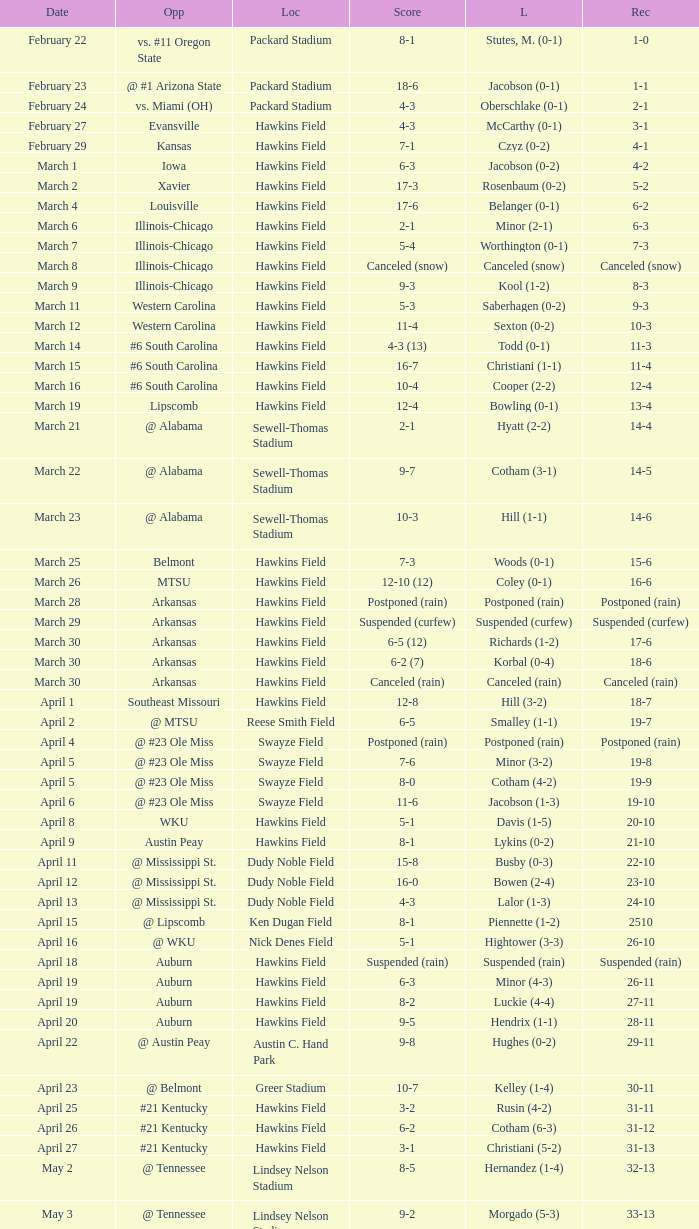What was the location of the game when the record was 12-4? Hawkins Field. Could you parse the entire table as a dict? {'header': ['Date', 'Opp', 'Loc', 'Score', 'L', 'Rec'], 'rows': [['February 22', 'vs. #11 Oregon State', 'Packard Stadium', '8-1', 'Stutes, M. (0-1)', '1-0'], ['February 23', '@ #1 Arizona State', 'Packard Stadium', '18-6', 'Jacobson (0-1)', '1-1'], ['February 24', 'vs. Miami (OH)', 'Packard Stadium', '4-3', 'Oberschlake (0-1)', '2-1'], ['February 27', 'Evansville', 'Hawkins Field', '4-3', 'McCarthy (0-1)', '3-1'], ['February 29', 'Kansas', 'Hawkins Field', '7-1', 'Czyz (0-2)', '4-1'], ['March 1', 'Iowa', 'Hawkins Field', '6-3', 'Jacobson (0-2)', '4-2'], ['March 2', 'Xavier', 'Hawkins Field', '17-3', 'Rosenbaum (0-2)', '5-2'], ['March 4', 'Louisville', 'Hawkins Field', '17-6', 'Belanger (0-1)', '6-2'], ['March 6', 'Illinois-Chicago', 'Hawkins Field', '2-1', 'Minor (2-1)', '6-3'], ['March 7', 'Illinois-Chicago', 'Hawkins Field', '5-4', 'Worthington (0-1)', '7-3'], ['March 8', 'Illinois-Chicago', 'Hawkins Field', 'Canceled (snow)', 'Canceled (snow)', 'Canceled (snow)'], ['March 9', 'Illinois-Chicago', 'Hawkins Field', '9-3', 'Kool (1-2)', '8-3'], ['March 11', 'Western Carolina', 'Hawkins Field', '5-3', 'Saberhagen (0-2)', '9-3'], ['March 12', 'Western Carolina', 'Hawkins Field', '11-4', 'Sexton (0-2)', '10-3'], ['March 14', '#6 South Carolina', 'Hawkins Field', '4-3 (13)', 'Todd (0-1)', '11-3'], ['March 15', '#6 South Carolina', 'Hawkins Field', '16-7', 'Christiani (1-1)', '11-4'], ['March 16', '#6 South Carolina', 'Hawkins Field', '10-4', 'Cooper (2-2)', '12-4'], ['March 19', 'Lipscomb', 'Hawkins Field', '12-4', 'Bowling (0-1)', '13-4'], ['March 21', '@ Alabama', 'Sewell-Thomas Stadium', '2-1', 'Hyatt (2-2)', '14-4'], ['March 22', '@ Alabama', 'Sewell-Thomas Stadium', '9-7', 'Cotham (3-1)', '14-5'], ['March 23', '@ Alabama', 'Sewell-Thomas Stadium', '10-3', 'Hill (1-1)', '14-6'], ['March 25', 'Belmont', 'Hawkins Field', '7-3', 'Woods (0-1)', '15-6'], ['March 26', 'MTSU', 'Hawkins Field', '12-10 (12)', 'Coley (0-1)', '16-6'], ['March 28', 'Arkansas', 'Hawkins Field', 'Postponed (rain)', 'Postponed (rain)', 'Postponed (rain)'], ['March 29', 'Arkansas', 'Hawkins Field', 'Suspended (curfew)', 'Suspended (curfew)', 'Suspended (curfew)'], ['March 30', 'Arkansas', 'Hawkins Field', '6-5 (12)', 'Richards (1-2)', '17-6'], ['March 30', 'Arkansas', 'Hawkins Field', '6-2 (7)', 'Korbal (0-4)', '18-6'], ['March 30', 'Arkansas', 'Hawkins Field', 'Canceled (rain)', 'Canceled (rain)', 'Canceled (rain)'], ['April 1', 'Southeast Missouri', 'Hawkins Field', '12-8', 'Hill (3-2)', '18-7'], ['April 2', '@ MTSU', 'Reese Smith Field', '6-5', 'Smalley (1-1)', '19-7'], ['April 4', '@ #23 Ole Miss', 'Swayze Field', 'Postponed (rain)', 'Postponed (rain)', 'Postponed (rain)'], ['April 5', '@ #23 Ole Miss', 'Swayze Field', '7-6', 'Minor (3-2)', '19-8'], ['April 5', '@ #23 Ole Miss', 'Swayze Field', '8-0', 'Cotham (4-2)', '19-9'], ['April 6', '@ #23 Ole Miss', 'Swayze Field', '11-6', 'Jacobson (1-3)', '19-10'], ['April 8', 'WKU', 'Hawkins Field', '5-1', 'Davis (1-5)', '20-10'], ['April 9', 'Austin Peay', 'Hawkins Field', '8-1', 'Lykins (0-2)', '21-10'], ['April 11', '@ Mississippi St.', 'Dudy Noble Field', '15-8', 'Busby (0-3)', '22-10'], ['April 12', '@ Mississippi St.', 'Dudy Noble Field', '16-0', 'Bowen (2-4)', '23-10'], ['April 13', '@ Mississippi St.', 'Dudy Noble Field', '4-3', 'Lalor (1-3)', '24-10'], ['April 15', '@ Lipscomb', 'Ken Dugan Field', '8-1', 'Piennette (1-2)', '2510'], ['April 16', '@ WKU', 'Nick Denes Field', '5-1', 'Hightower (3-3)', '26-10'], ['April 18', 'Auburn', 'Hawkins Field', 'Suspended (rain)', 'Suspended (rain)', 'Suspended (rain)'], ['April 19', 'Auburn', 'Hawkins Field', '6-3', 'Minor (4-3)', '26-11'], ['April 19', 'Auburn', 'Hawkins Field', '8-2', 'Luckie (4-4)', '27-11'], ['April 20', 'Auburn', 'Hawkins Field', '9-5', 'Hendrix (1-1)', '28-11'], ['April 22', '@ Austin Peay', 'Austin C. Hand Park', '9-8', 'Hughes (0-2)', '29-11'], ['April 23', '@ Belmont', 'Greer Stadium', '10-7', 'Kelley (1-4)', '30-11'], ['April 25', '#21 Kentucky', 'Hawkins Field', '3-2', 'Rusin (4-2)', '31-11'], ['April 26', '#21 Kentucky', 'Hawkins Field', '6-2', 'Cotham (6-3)', '31-12'], ['April 27', '#21 Kentucky', 'Hawkins Field', '3-1', 'Christiani (5-2)', '31-13'], ['May 2', '@ Tennessee', 'Lindsey Nelson Stadium', '8-5', 'Hernandez (1-4)', '32-13'], ['May 3', '@ Tennessee', 'Lindsey Nelson Stadium', '9-2', 'Morgado (5-3)', '33-13'], ['May 4', '@ Tennessee', 'Lindsey Nelson Stadium', '10-8', 'Wiltz (3-2)', '34-13'], ['May 6', 'vs. Memphis', 'Pringles Park', '8-0', 'Martin (4-3)', '35-13'], ['May 7', 'Tennessee Tech', 'Hawkins Field', '7-2', 'Liberatore (1-1)', '36-13'], ['May 9', '#9 Georgia', 'Hawkins Field', '13-7', 'Holder (7-3)', '37-13'], ['May 10', '#9 Georgia', 'Hawkins Field', '4-2 (10)', 'Brewer (4-1)', '37-14'], ['May 11', '#9 Georgia', 'Hawkins Field', '12-10', 'Christiani (5-3)', '37-15'], ['May 15', '@ Florida', 'McKethan Stadium', '8-6', 'Brewer (4-2)', '37-16'], ['May 16', '@ Florida', 'McKethan Stadium', '5-4', 'Cotham (7-4)', '37-17'], ['May 17', '@ Florida', 'McKethan Stadium', '13-12 (11)', 'Jacobson (1-4)', '37-18']]} 